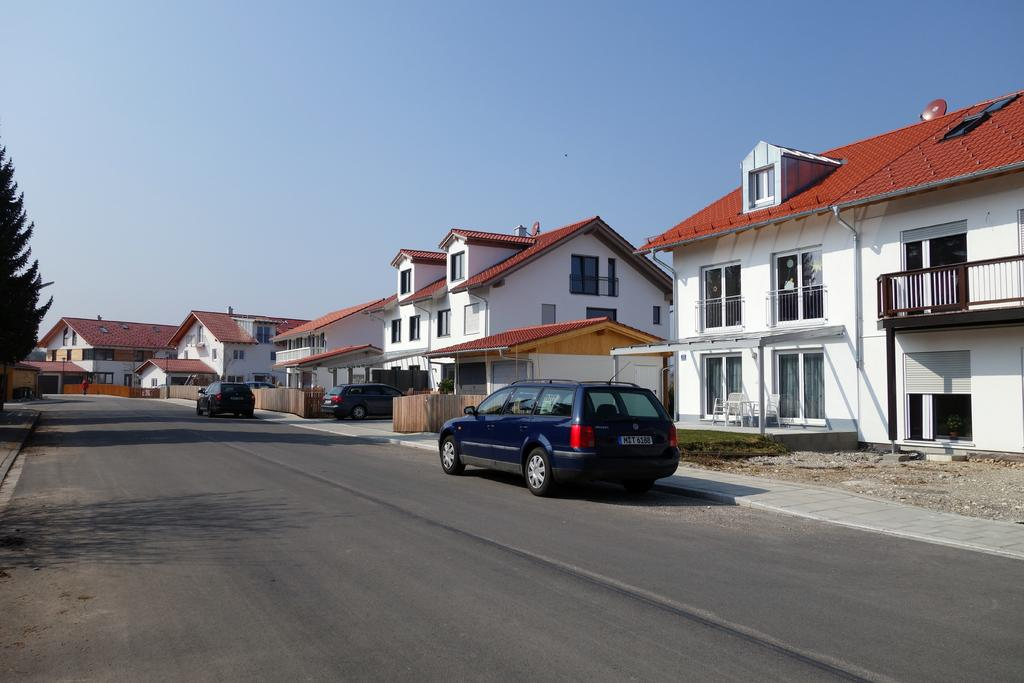What can be seen on the road in the image? There are vehicles on the road in the image. Is there anyone else on the road besides the vehicles? Yes, there is a person on the road in the image. What can be seen in the distance behind the road? There are buildings, fences, and a tree in the background of the image. What is visible at the top of the image? The sky is visible at the top of the image. What type of toothpaste is being used by the person on the road in the image? There is no toothpaste present in the image, as it features vehicles, a person, and background elements such as buildings, fences, and a tree. What nerve is being stimulated by the person on the road in the image? There is no indication in the image that the person's nerves are being stimulated, as they are simply walking on the road. 